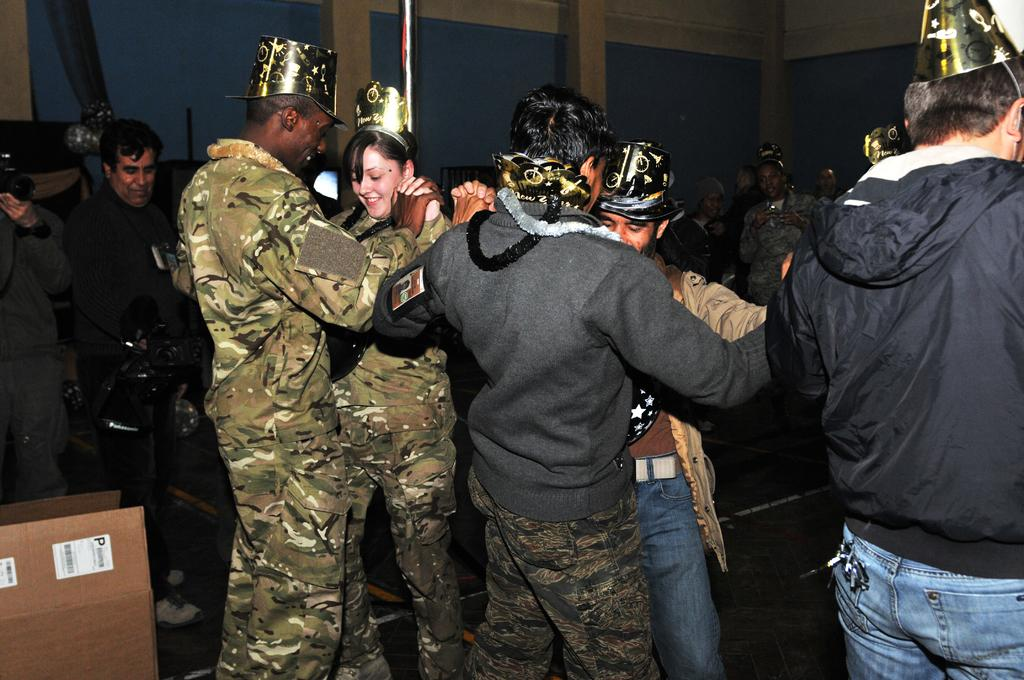What are the persons in the image doing? The persons in the image are holding hands. What can be seen at the top of the image? There are beams at the top of the image. What object is located on the left side of the image? There is a cardboard box on the left side of the image. What type of hen can be seen in the image? There is no hen present in the image. Is the scene taking place during the night in the image? The image does not provide any information about the time of day, so it cannot be determined if it is night or not. 